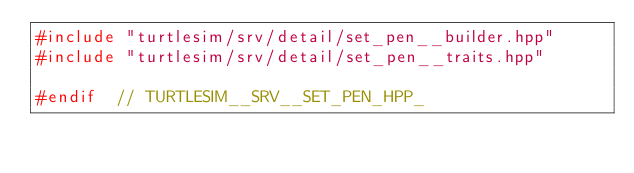<code> <loc_0><loc_0><loc_500><loc_500><_C++_>#include "turtlesim/srv/detail/set_pen__builder.hpp"
#include "turtlesim/srv/detail/set_pen__traits.hpp"

#endif  // TURTLESIM__SRV__SET_PEN_HPP_
</code> 